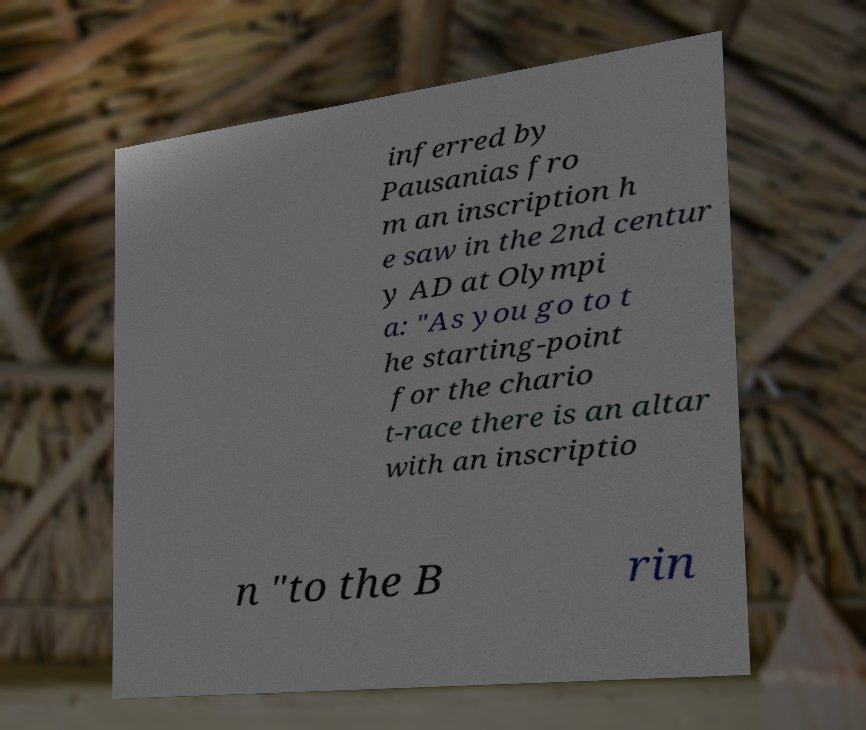For documentation purposes, I need the text within this image transcribed. Could you provide that? inferred by Pausanias fro m an inscription h e saw in the 2nd centur y AD at Olympi a: "As you go to t he starting-point for the chario t-race there is an altar with an inscriptio n "to the B rin 